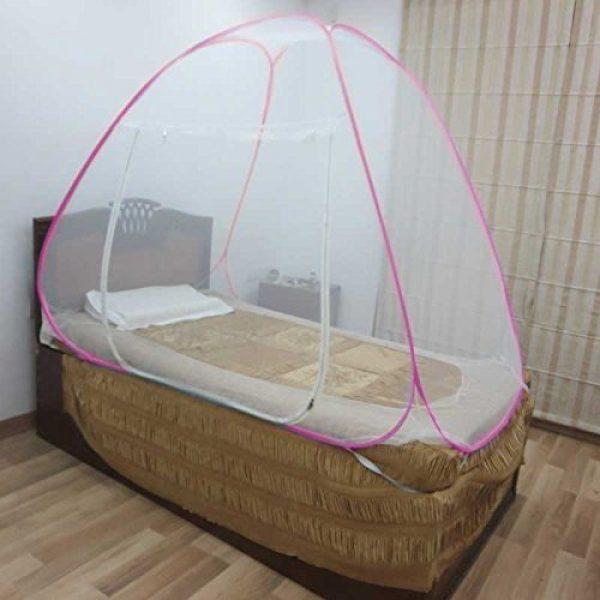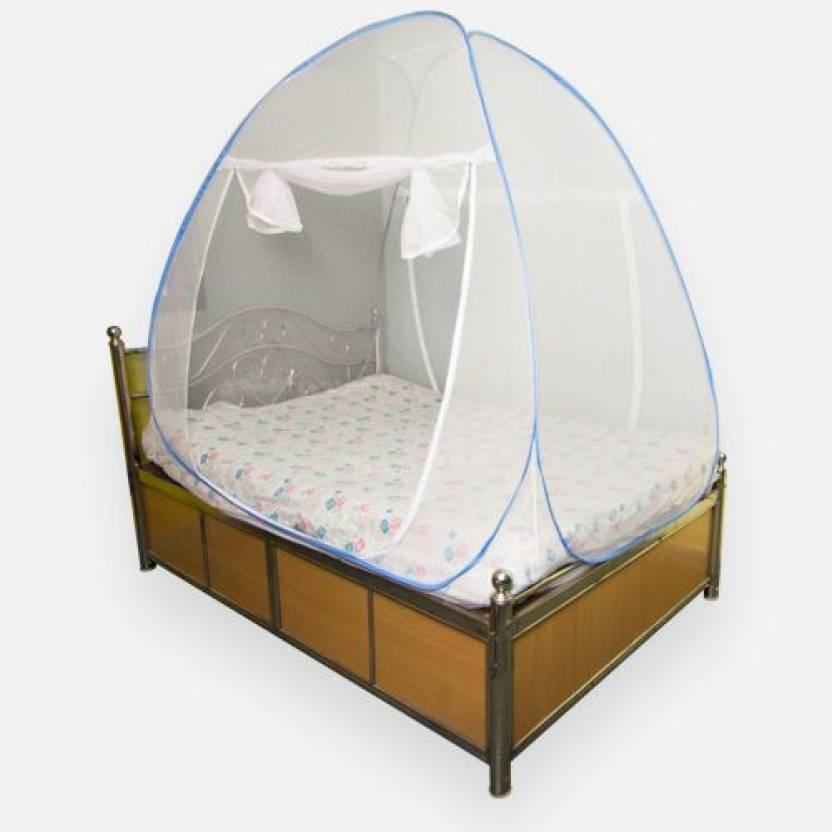The first image is the image on the left, the second image is the image on the right. Given the left and right images, does the statement "Two or more pillows are visible." hold true? Answer yes or no. No. The first image is the image on the left, the second image is the image on the right. For the images shown, is this caption "There are two pillows in the right image." true? Answer yes or no. No. 